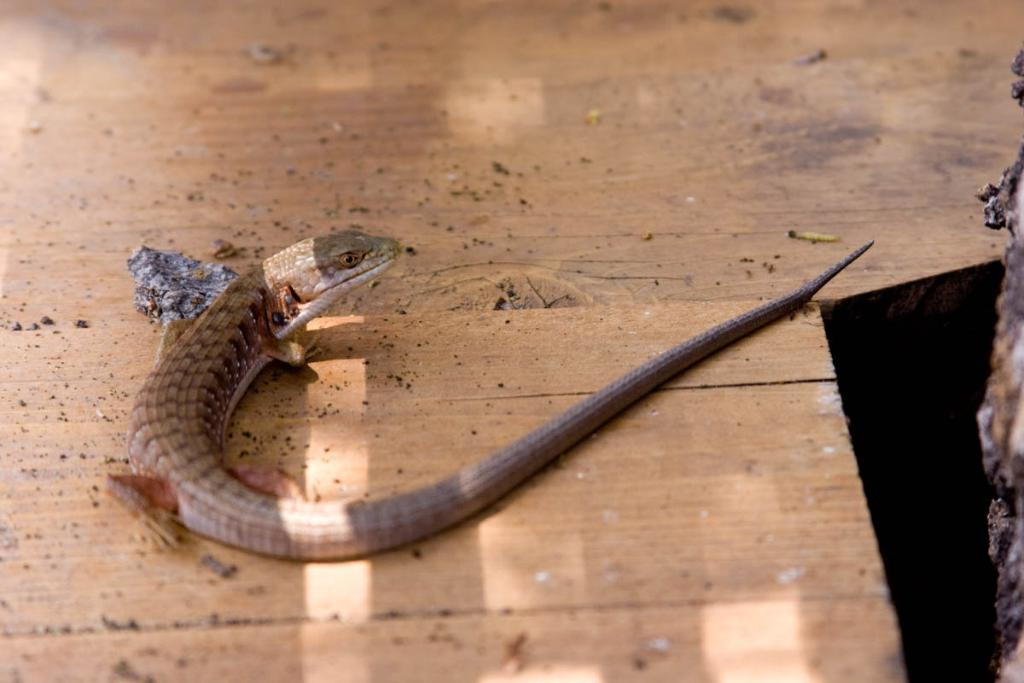What is the main subject of the image? There is a snake on the wooden floor in the center of the image. Can you describe any other objects in the image? There are a few other objects in the image, but their specific details are not mentioned in the provided facts. What is the color of the object on the right side of the image? There is a black color object on the right side of the image. Are there any other objects on the right side of the image? Yes, there is one more object on the right side of the image. What type of bean is being used as a source of authority in the image? There is no bean or reference to authority present in the image. 